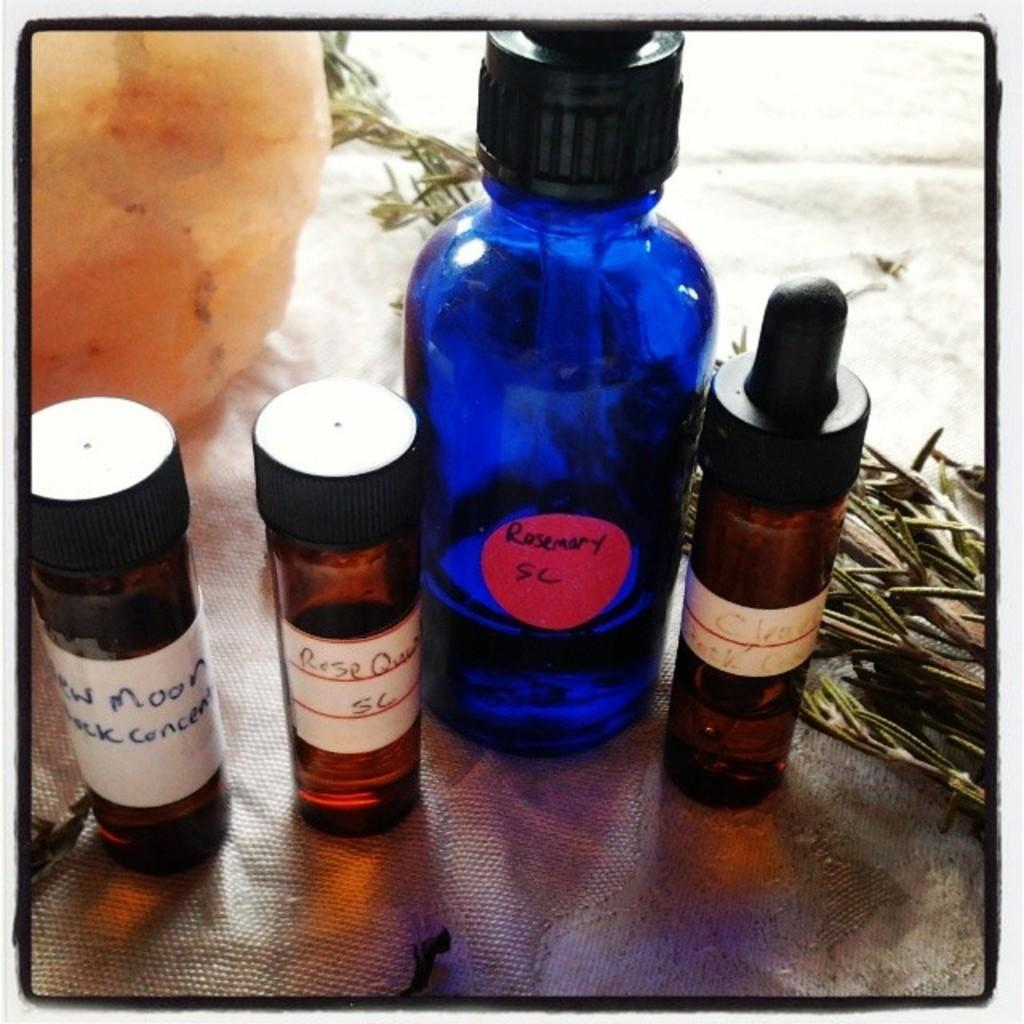<image>
Describe the image concisely. A blue container has a red sticker that says Rosemary SC. 